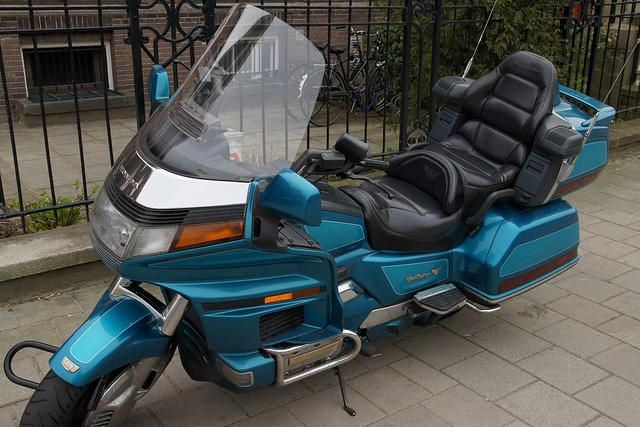How many people can ride this motorcycle at a time? two 